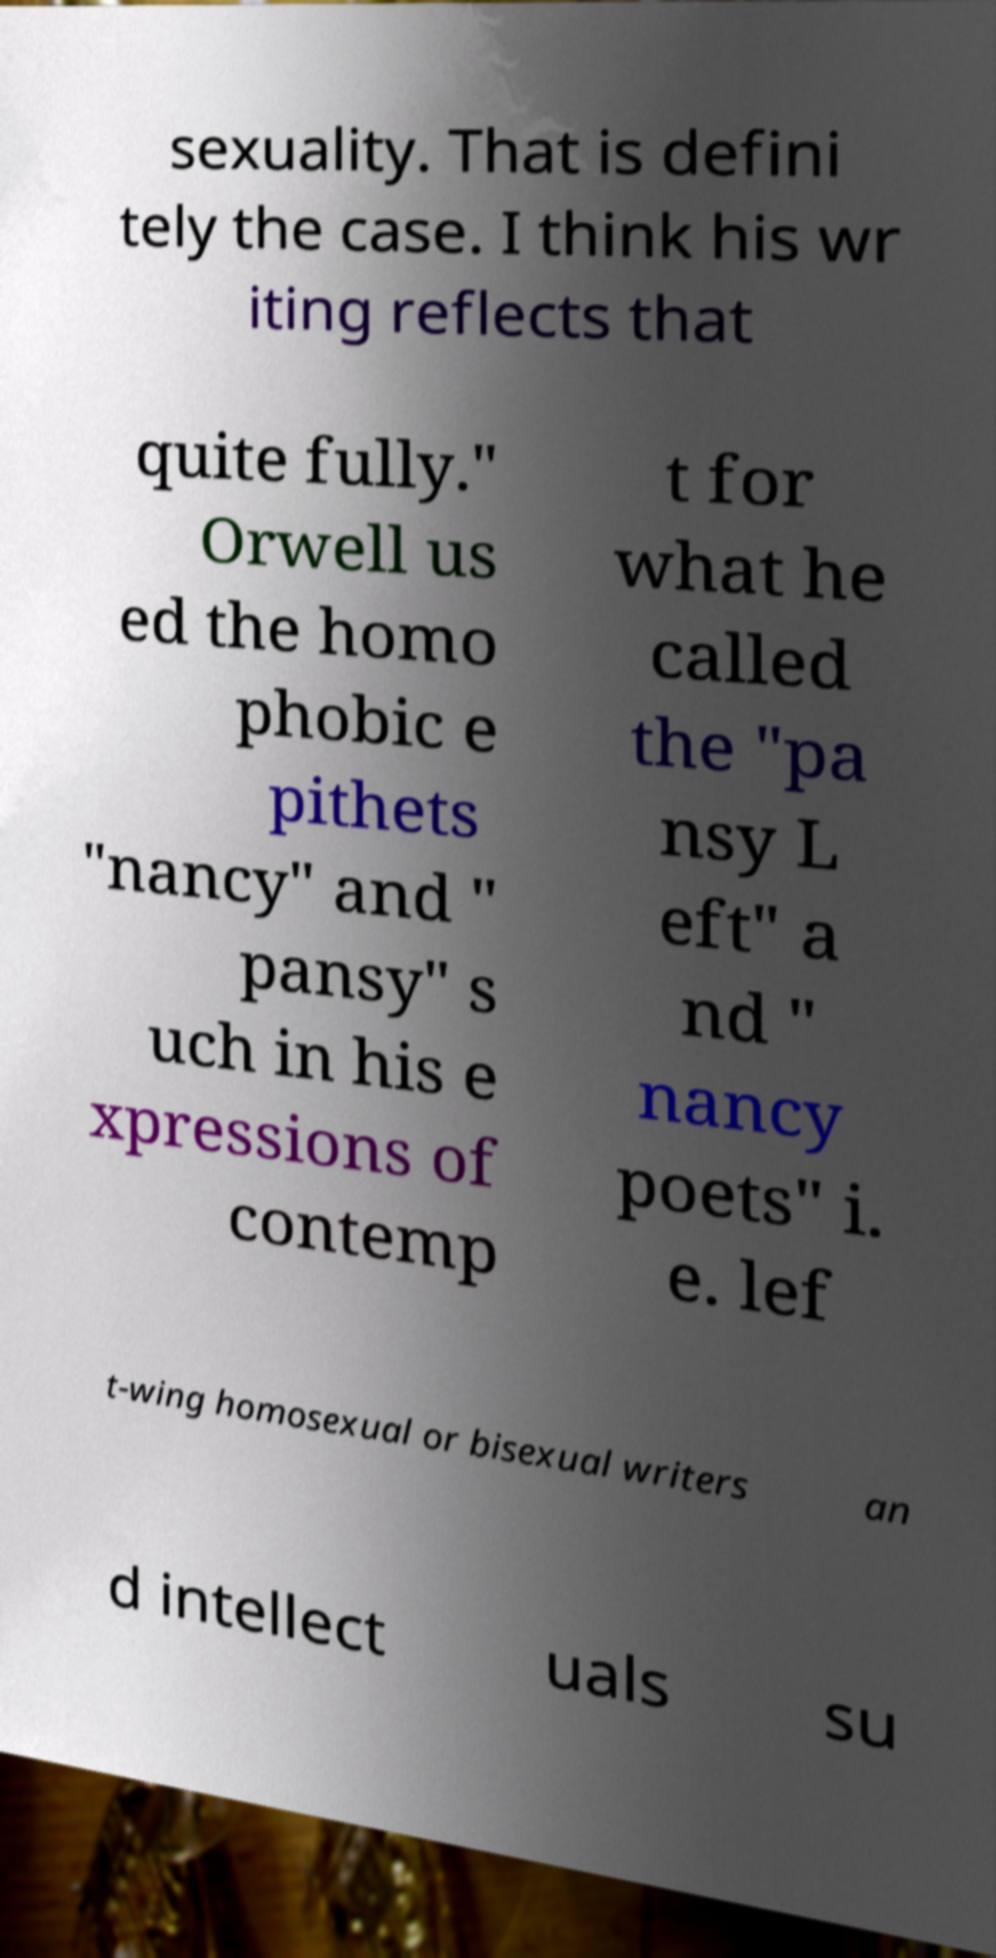What messages or text are displayed in this image? I need them in a readable, typed format. sexuality. That is defini tely the case. I think his wr iting reflects that quite fully." Orwell us ed the homo phobic e pithets "nancy" and " pansy" s uch in his e xpressions of contemp t for what he called the "pa nsy L eft" a nd " nancy poets" i. e. lef t-wing homosexual or bisexual writers an d intellect uals su 